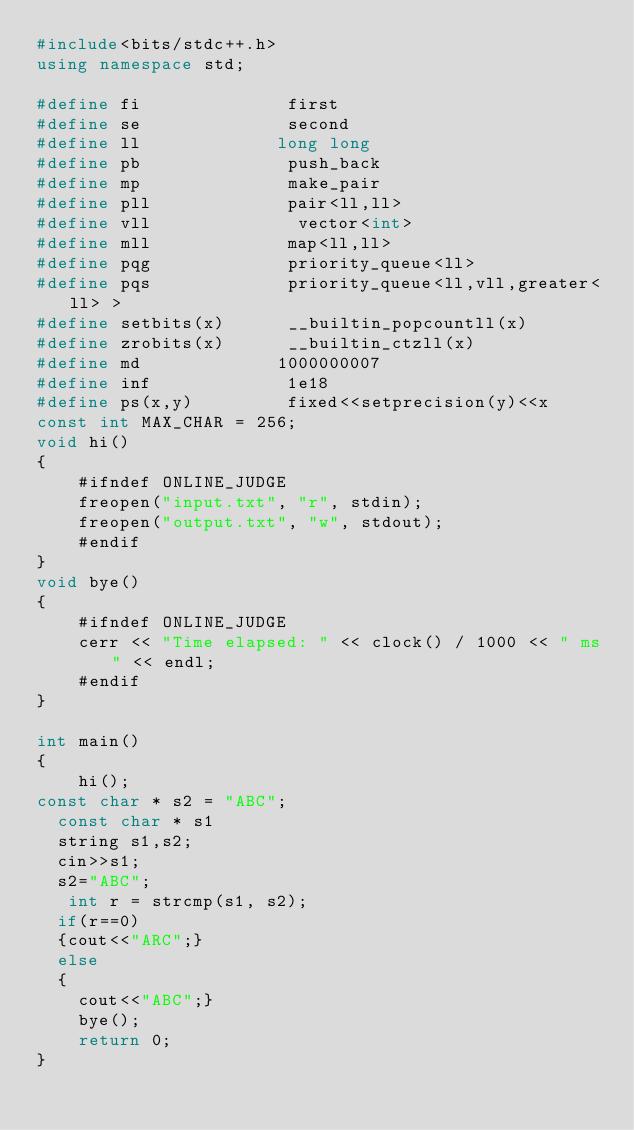<code> <loc_0><loc_0><loc_500><loc_500><_C++_>#include<bits/stdc++.h>
using namespace std;

#define fi              first
#define se              second
#define ll             long long
#define pb              push_back
#define mp              make_pair
#define pll             pair<ll,ll>
#define vll              vector<int>
#define mll             map<ll,ll>
#define pqg             priority_queue<ll>
#define pqs             priority_queue<ll,vll,greater<ll> >
#define setbits(x)      __builtin_popcountll(x)
#define zrobits(x)      __builtin_ctzll(x)
#define md             1000000007
#define inf             1e18
#define ps(x,y)         fixed<<setprecision(y)<<x
const int MAX_CHAR = 256;
void hi()
{
    #ifndef ONLINE_JUDGE
    freopen("input.txt", "r", stdin);
    freopen("output.txt", "w", stdout);
    #endif
}
void bye()
{
    #ifndef ONLINE_JUDGE
    cerr << "Time elapsed: " << clock() / 1000 << " ms" << endl;
    #endif
}

int main()
{
    hi();
const char * s2 = "ABC";
  const char * s1
  string s1,s2;
  cin>>s1;
  s2="ABC";
   int r = strcmp(s1, s2);
  if(r==0)
  {cout<<"ARC";}
  else
  {
    cout<<"ABC";}
    bye();
    return 0;
}
</code> 